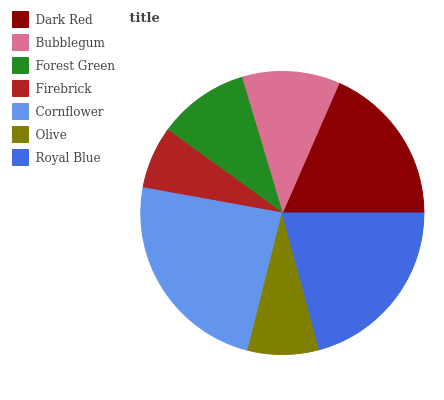Is Firebrick the minimum?
Answer yes or no. Yes. Is Cornflower the maximum?
Answer yes or no. Yes. Is Bubblegum the minimum?
Answer yes or no. No. Is Bubblegum the maximum?
Answer yes or no. No. Is Dark Red greater than Bubblegum?
Answer yes or no. Yes. Is Bubblegum less than Dark Red?
Answer yes or no. Yes. Is Bubblegum greater than Dark Red?
Answer yes or no. No. Is Dark Red less than Bubblegum?
Answer yes or no. No. Is Bubblegum the high median?
Answer yes or no. Yes. Is Bubblegum the low median?
Answer yes or no. Yes. Is Olive the high median?
Answer yes or no. No. Is Cornflower the low median?
Answer yes or no. No. 